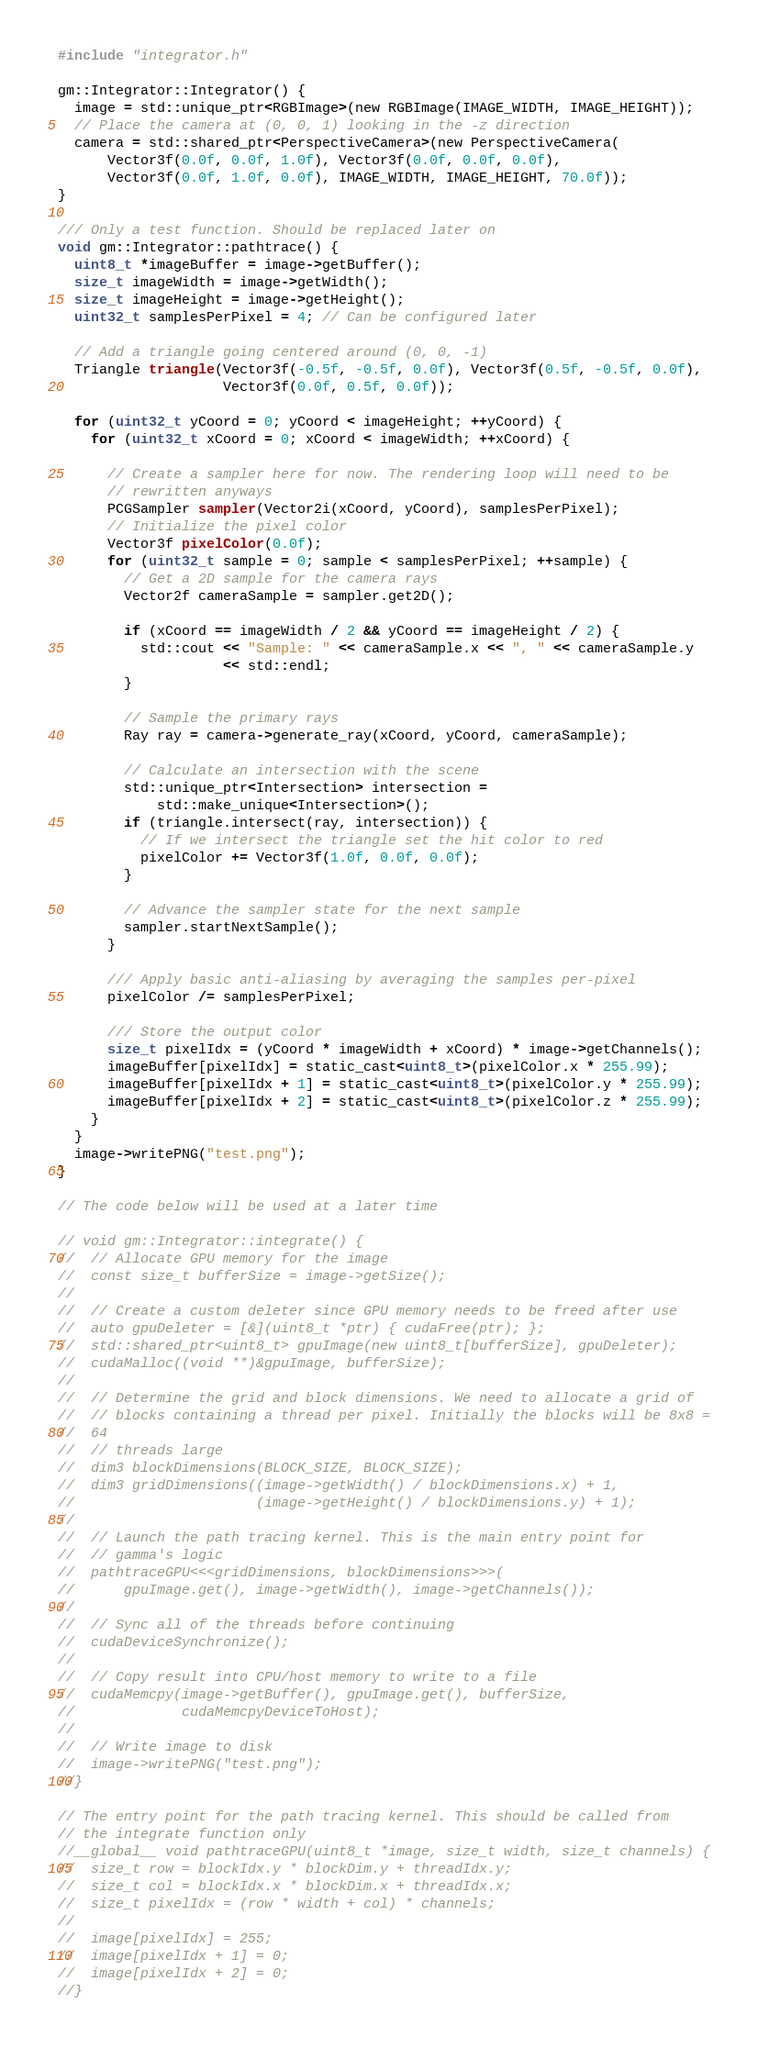Convert code to text. <code><loc_0><loc_0><loc_500><loc_500><_Cuda_>#include "integrator.h"

gm::Integrator::Integrator() {
  image = std::unique_ptr<RGBImage>(new RGBImage(IMAGE_WIDTH, IMAGE_HEIGHT));
  // Place the camera at (0, 0, 1) looking in the -z direction
  camera = std::shared_ptr<PerspectiveCamera>(new PerspectiveCamera(
      Vector3f(0.0f, 0.0f, 1.0f), Vector3f(0.0f, 0.0f, 0.0f),
      Vector3f(0.0f, 1.0f, 0.0f), IMAGE_WIDTH, IMAGE_HEIGHT, 70.0f));
}

/// Only a test function. Should be replaced later on
void gm::Integrator::pathtrace() {
  uint8_t *imageBuffer = image->getBuffer();
  size_t imageWidth = image->getWidth();
  size_t imageHeight = image->getHeight();
  uint32_t samplesPerPixel = 4; // Can be configured later

  // Add a triangle going centered around (0, 0, -1)
  Triangle triangle(Vector3f(-0.5f, -0.5f, 0.0f), Vector3f(0.5f, -0.5f, 0.0f),
                    Vector3f(0.0f, 0.5f, 0.0f));

  for (uint32_t yCoord = 0; yCoord < imageHeight; ++yCoord) {
    for (uint32_t xCoord = 0; xCoord < imageWidth; ++xCoord) {

      // Create a sampler here for now. The rendering loop will need to be
      // rewritten anyways
      PCGSampler sampler(Vector2i(xCoord, yCoord), samplesPerPixel);
      // Initialize the pixel color
      Vector3f pixelColor(0.0f);
      for (uint32_t sample = 0; sample < samplesPerPixel; ++sample) {
        // Get a 2D sample for the camera rays
        Vector2f cameraSample = sampler.get2D();

        if (xCoord == imageWidth / 2 && yCoord == imageHeight / 2) {
          std::cout << "Sample: " << cameraSample.x << ", " << cameraSample.y
                    << std::endl;
        }

        // Sample the primary rays
        Ray ray = camera->generate_ray(xCoord, yCoord, cameraSample);

        // Calculate an intersection with the scene
        std::unique_ptr<Intersection> intersection =
            std::make_unique<Intersection>();
        if (triangle.intersect(ray, intersection)) {
          // If we intersect the triangle set the hit color to red
          pixelColor += Vector3f(1.0f, 0.0f, 0.0f);
        }

        // Advance the sampler state for the next sample
        sampler.startNextSample();
      }

      /// Apply basic anti-aliasing by averaging the samples per-pixel
      pixelColor /= samplesPerPixel;

      /// Store the output color
      size_t pixelIdx = (yCoord * imageWidth + xCoord) * image->getChannels();
      imageBuffer[pixelIdx] = static_cast<uint8_t>(pixelColor.x * 255.99);
      imageBuffer[pixelIdx + 1] = static_cast<uint8_t>(pixelColor.y * 255.99);
      imageBuffer[pixelIdx + 2] = static_cast<uint8_t>(pixelColor.z * 255.99);
    }
  }
  image->writePNG("test.png");
}

// The code below will be used at a later time

// void gm::Integrator::integrate() {
//  // Allocate GPU memory for the image
//  const size_t bufferSize = image->getSize();
//
//  // Create a custom deleter since GPU memory needs to be freed after use
//  auto gpuDeleter = [&](uint8_t *ptr) { cudaFree(ptr); };
//  std::shared_ptr<uint8_t> gpuImage(new uint8_t[bufferSize], gpuDeleter);
//  cudaMalloc((void **)&gpuImage, bufferSize);
//
//  // Determine the grid and block dimensions. We need to allocate a grid of
//  // blocks containing a thread per pixel. Initially the blocks will be 8x8 =
//  64
//  // threads large
//  dim3 blockDimensions(BLOCK_SIZE, BLOCK_SIZE);
//  dim3 gridDimensions((image->getWidth() / blockDimensions.x) + 1,
//                      (image->getHeight() / blockDimensions.y) + 1);
//
//  // Launch the path tracing kernel. This is the main entry point for
//  // gamma's logic
//  pathtraceGPU<<<gridDimensions, blockDimensions>>>(
//      gpuImage.get(), image->getWidth(), image->getChannels());
//
//  // Sync all of the threads before continuing
//  cudaDeviceSynchronize();
//
//  // Copy result into CPU/host memory to write to a file
//  cudaMemcpy(image->getBuffer(), gpuImage.get(), bufferSize,
//             cudaMemcpyDeviceToHost);
//
//  // Write image to disk
//  image->writePNG("test.png");
//}

// The entry point for the path tracing kernel. This should be called from
// the integrate function only
//__global__ void pathtraceGPU(uint8_t *image, size_t width, size_t channels) {
//  size_t row = blockIdx.y * blockDim.y + threadIdx.y;
//  size_t col = blockIdx.x * blockDim.x + threadIdx.x;
//  size_t pixelIdx = (row * width + col) * channels;
//
//  image[pixelIdx] = 255;
//  image[pixelIdx + 1] = 0;
//  image[pixelIdx + 2] = 0;
//}</code> 